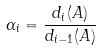<formula> <loc_0><loc_0><loc_500><loc_500>\alpha _ { i } = \frac { d _ { i } ( A ) } { d _ { i - 1 } ( A ) }</formula> 